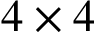Convert formula to latex. <formula><loc_0><loc_0><loc_500><loc_500>4 \times 4</formula> 